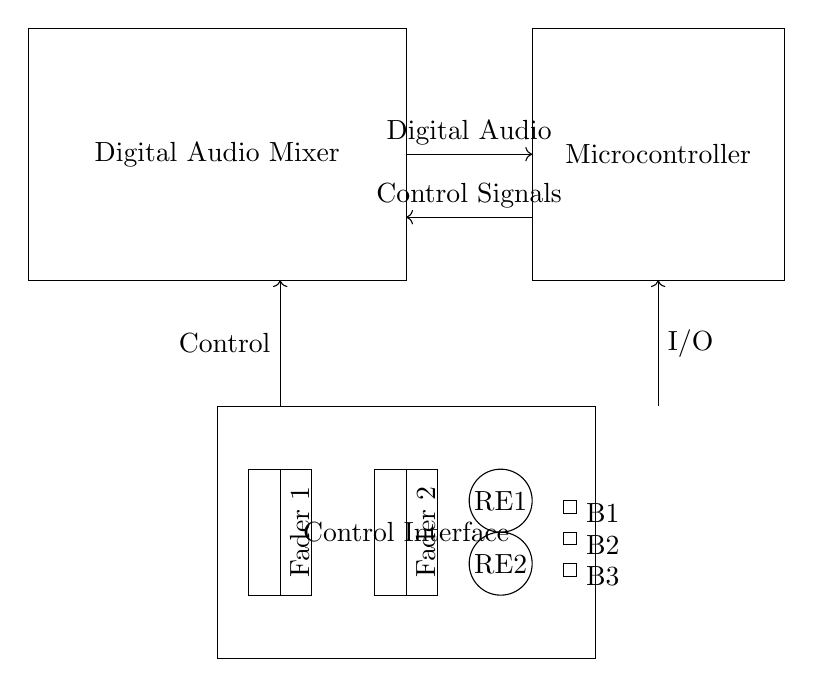What is the main component of this circuit? The main component is the Digital Audio Mixer, which is represented as a rectangle in the circuit diagram.
Answer: Digital Audio Mixer How many faders are included in the control interface? There are two faders shown in the control interface section of the circuit, indicated by the labeled rectangles.
Answer: Two What is the purpose of the rotary encoders in this circuit? The rotary encoders are typically used for adjusting parameters, such as volume or pan, by turning them, which affects the control signals sent to the mixer.
Answer: Adjusting parameters What are the control signals flowing to and from the microcontroller? The control signals flow in both directions between the Digital Audio Mixer and the Microcontroller as indicated by the arrows, showing a bidirectional communication for controls and feedback.
Answer: Bidirectional communication Which components are represented as buttons? The buttons are represented as small rectangles labeled B1, B2, and B3, located in the control interface area.
Answer: B1, B2, B3 What type of signals are output from the microcontroller? The microcontroller outputs digital audio signals, as indicated by the labeling of the outgoing arrow from the microcontroller.
Answer: Digital audio What does the connection at the top represent? The connection at the top represents the flow of digital audio signals from the Digital Audio Mixer to the Microcontroller, essential for processing audio data.
Answer: Digital audio signals flow 